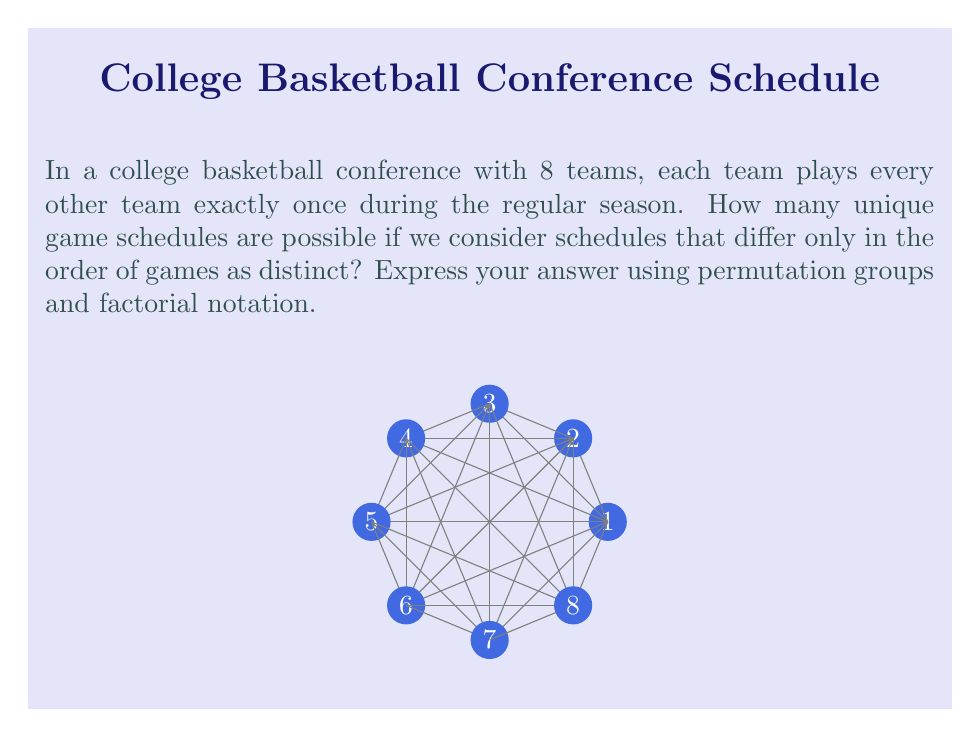Show me your answer to this math problem. Let's approach this step-by-step:

1) First, we need to calculate the total number of games in the season. With 8 teams, each team plays 7 other teams once. The total number of games is:

   $$ \frac{8 \times 7}{2} = 28 $$

2) Now, we can think of each unique schedule as a permutation of these 28 games. The total number of permutations of 28 objects is 28!.

3) However, this overcounts the number of unique schedules. We need to account for symmetries in the schedule that don't actually create distinct schedules.

4) In this case, the order of games on each day doesn't matter. For example, if Team 1 plays Team 2 and Team 3 plays Team 4 on the same day, swapping these games doesn't create a new schedule.

5) There are 4 games played each day (since there are 8 teams), and we have 7 days of games (28 games total / 4 games per day).

6) For each day, the number of ways to arrange 4 games is 4! = 24.

7) We have 7 such days, so we need to divide our total by $(4!)^7$.

8) Therefore, the number of unique schedules is:

   $$ \frac{28!}{(4!)^7} $$

This formula uses permutation groups to count the number of unique schedules while accounting for symmetries that don't create distinct schedules.
Answer: $\frac{28!}{(4!)^7}$ 